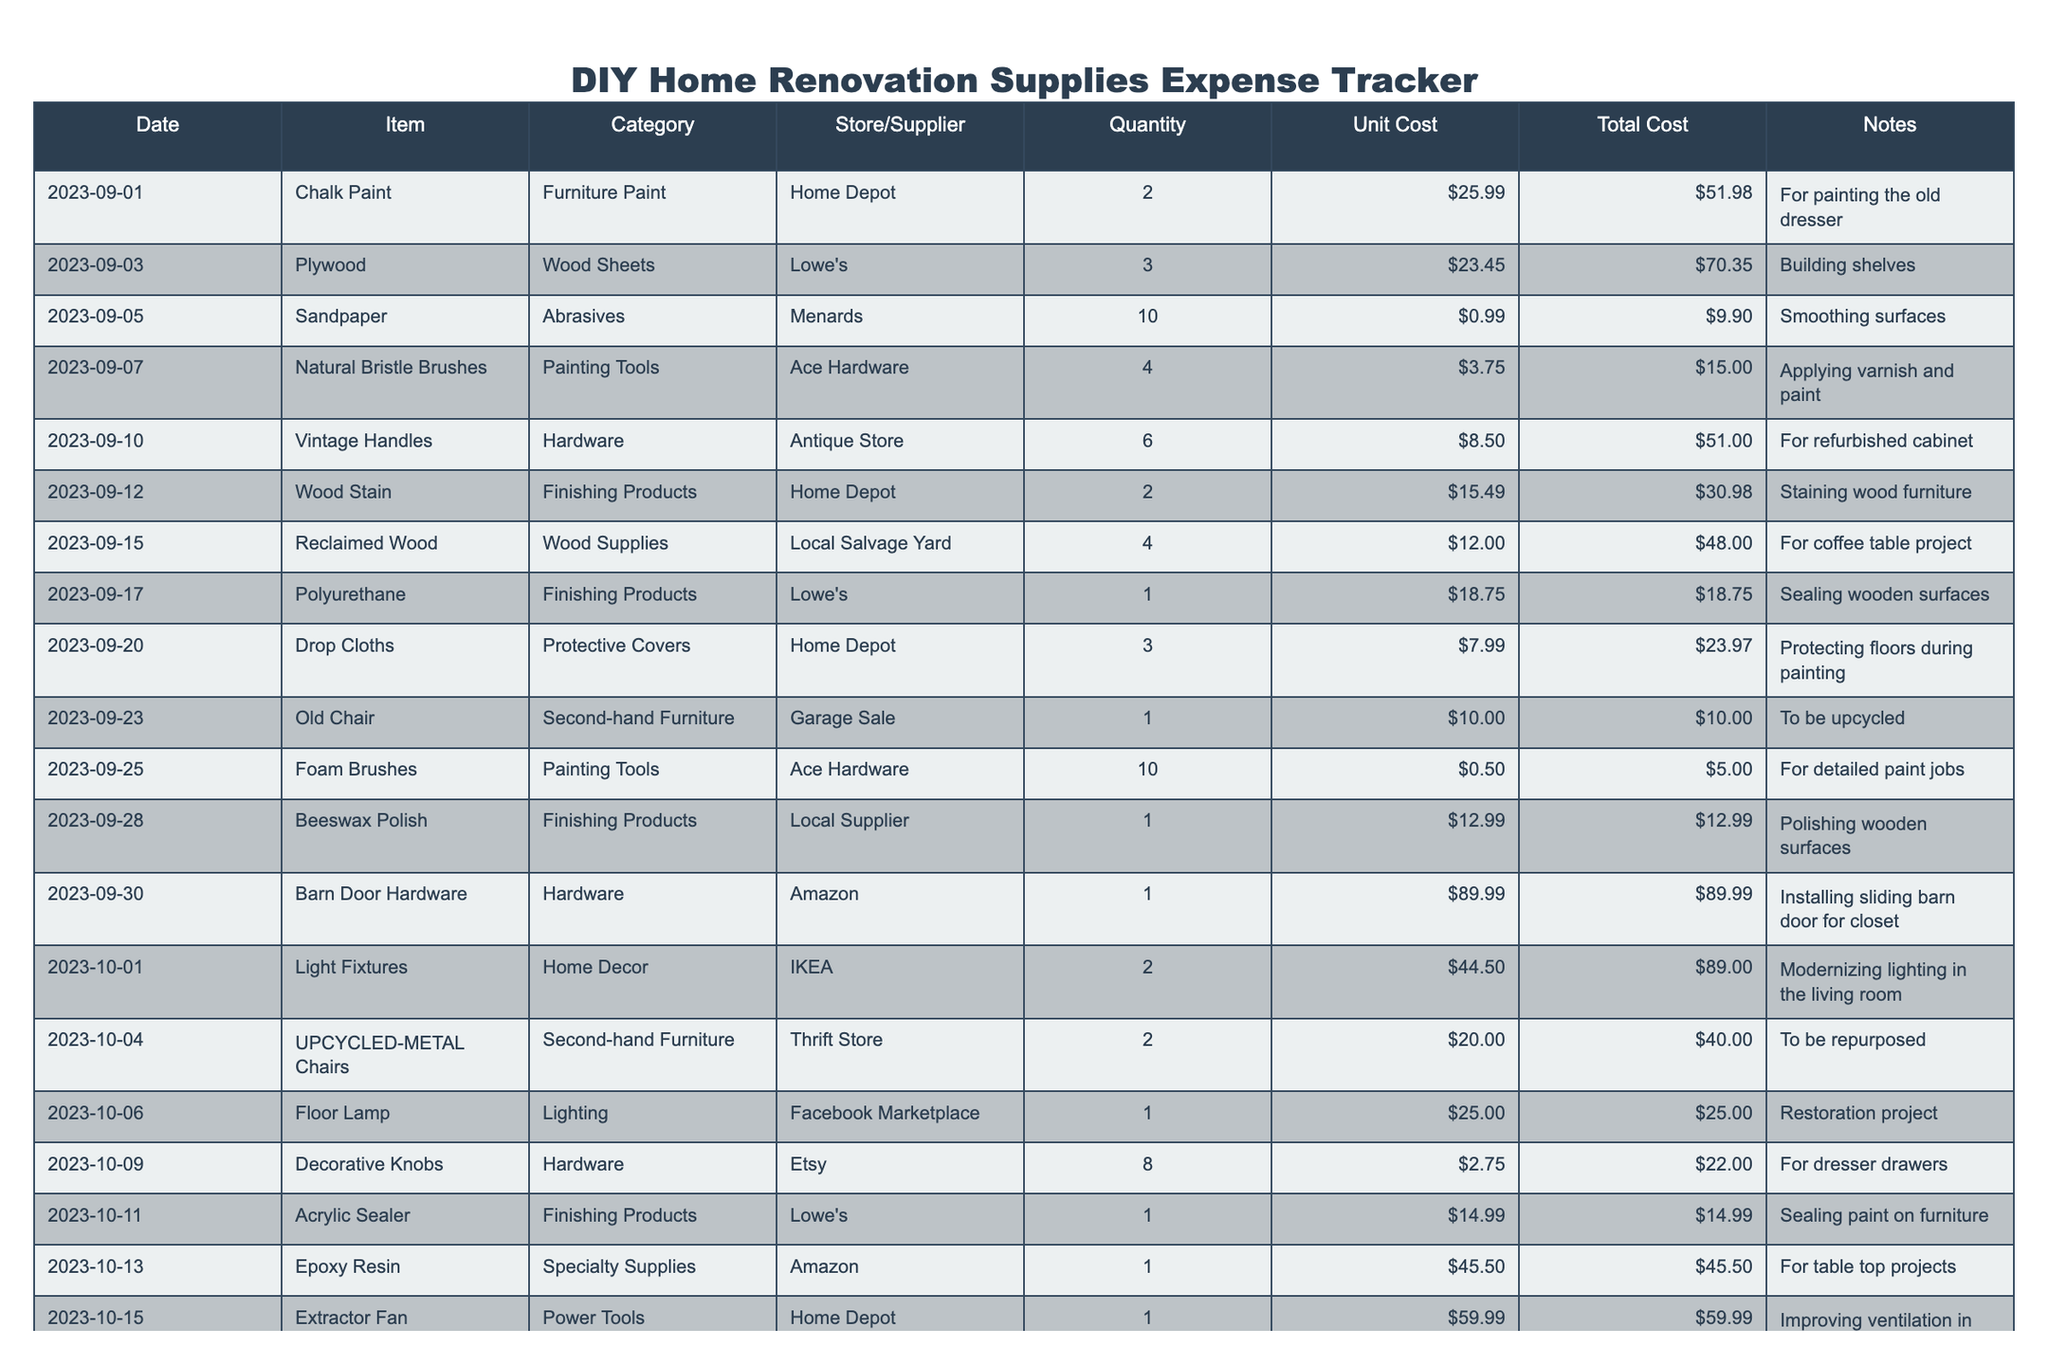What was the total cost of the chalk paint? The total cost for chalk paint is listed in the "Total Cost" column next to the "Chalk Paint" row. It states $51.98.
Answer: $51.98 How much was spent on second-hand furniture items? The second-hand furniture items are the "Old Chair" and "UPCYCLED-METAL Chairs." Adding their costs: $10.00 + $40.00 = $50.00.
Answer: $50.00 Which store supplied the most expensive item on the list? The item with the highest total cost is "Barn Door Hardware," which cost $89.99 and is from Amazon.
Answer: Amazon What is the average unit cost for all painting tools? The painting tools listed are "Natural Bristle Brushes" and "Foam Brushes." Their unit costs are $3.75 and $0.50. The average is calculated as (3.75 + 0.50) / 2 = 2.125.
Answer: $2.13 Did you purchase wood stain for any projects? Yes, there is a line item for "Wood Stain," which was purchased on 2023-09-12 for a total of $30.98.
Answer: Yes What is the total amount spent on finishing products? The finishing products include "Wood Stain," "Polyurethane," "Beeswax Polish," and "Acrylic Sealer." Their costs are: $30.98 + $18.75 + $12.99 + $14.99 = $77.71.
Answer: $77.71 Which category had the highest total spending? By calculating total costs for each category, we can see that "Hardware" had $51.00 + $89.99 = $140.99, while "Finishing Products" totals $77.71. Therefore, "Hardware" is the highest.
Answer: Hardware How many different types of paint were purchased in total? The types of paint are "Chalk Paint" and "Wood Stain," so there are 2 different types of paint bought.
Answer: 2 What was the total cost of the supplies bought from Home Depot? The items bought from Home Depot include "Chalk Paint" ($51.98), "Wood Stain" ($30.98), "Drop Cloths" ($23.97), and "Extractor Fan" ($59.99). Summing these: 51.98 + 30.98 + 23.97 + 59.99 = 166.92.
Answer: $166.92 